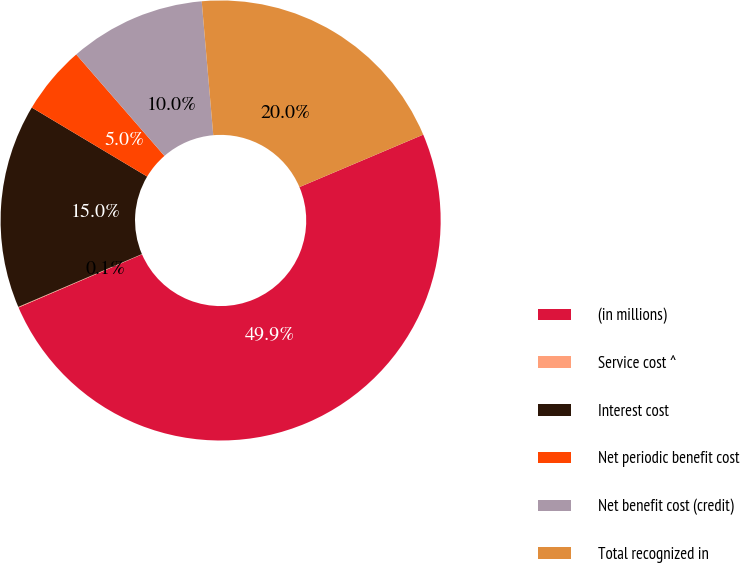Convert chart. <chart><loc_0><loc_0><loc_500><loc_500><pie_chart><fcel>(in millions)<fcel>Service cost ^<fcel>Interest cost<fcel>Net periodic benefit cost<fcel>Net benefit cost (credit)<fcel>Total recognized in<nl><fcel>49.9%<fcel>0.05%<fcel>15.0%<fcel>5.03%<fcel>10.02%<fcel>19.99%<nl></chart> 